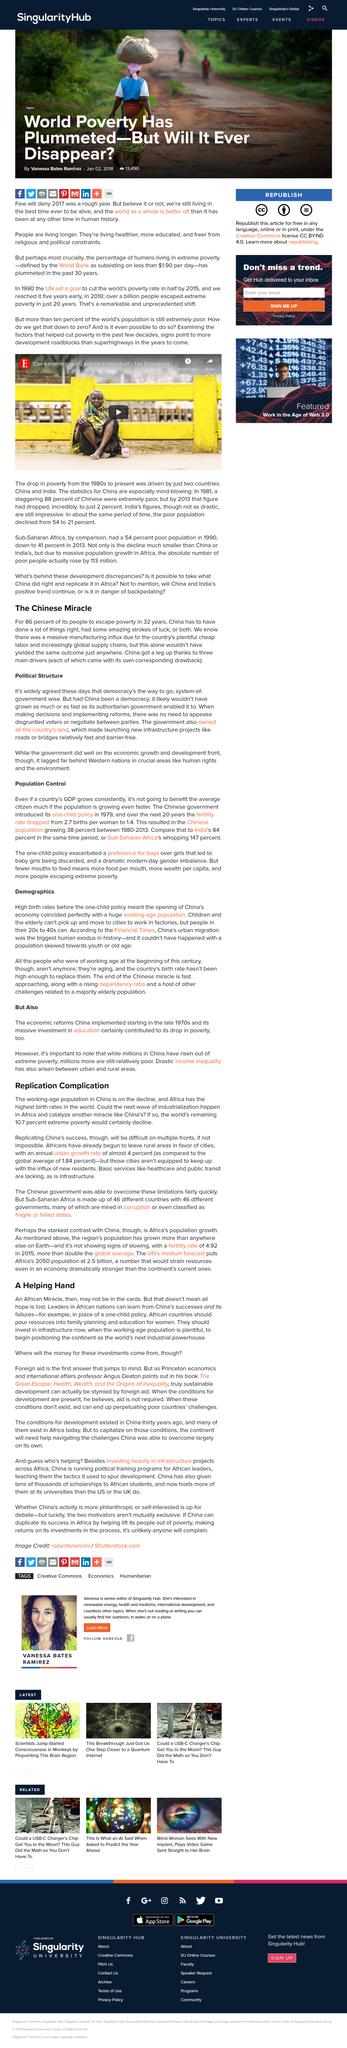Point out several critical features in this image. Angus Deaton's book is titled 'The Great Escape: Health, Wealth, and the Origins of Inequality,' which explores the connection between economic development, health and wealth inequality. It is hypothetically asserted that a democratic government system would not have achieved the rapid poverty alleviation that was achieved by the then authoritarian government in China. The drop in poverty levels since the 1980s was driven by China and India, making them two of the key countries responsible for reducing poverty globally. The writers of the article hope for the eradication of extreme poverty. China's policy is being used as an example for African nations to learn from in regards to [insert specific topic]. 